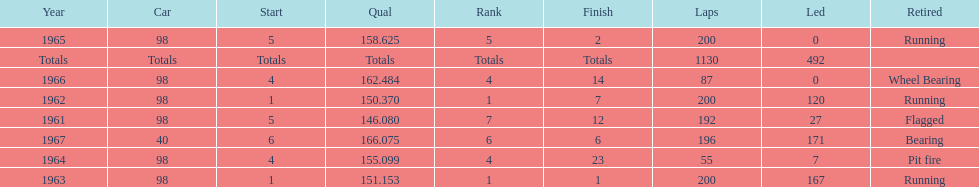Number of times to finish the races running. 3. 